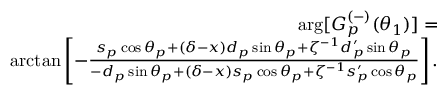Convert formula to latex. <formula><loc_0><loc_0><loc_500><loc_500>\begin{array} { r l r } & { \arg [ G _ { p } ^ { ( - ) } ( \theta _ { 1 } ) ] = } \\ & { \arctan \left [ - \frac { s _ { p } \cos \theta _ { p } + \left ( \delta - x \right ) d _ { p } \sin \theta _ { p } + \zeta ^ { - 1 } d _ { p } ^ { \prime } \sin \theta _ { p } } { - d _ { p } \sin \theta _ { p } + \left ( \delta - x \right ) s _ { p } \cos \theta _ { p } + \zeta ^ { - 1 } s _ { p } ^ { \prime } \cos \theta _ { p } } \right ] . } \end{array}</formula> 